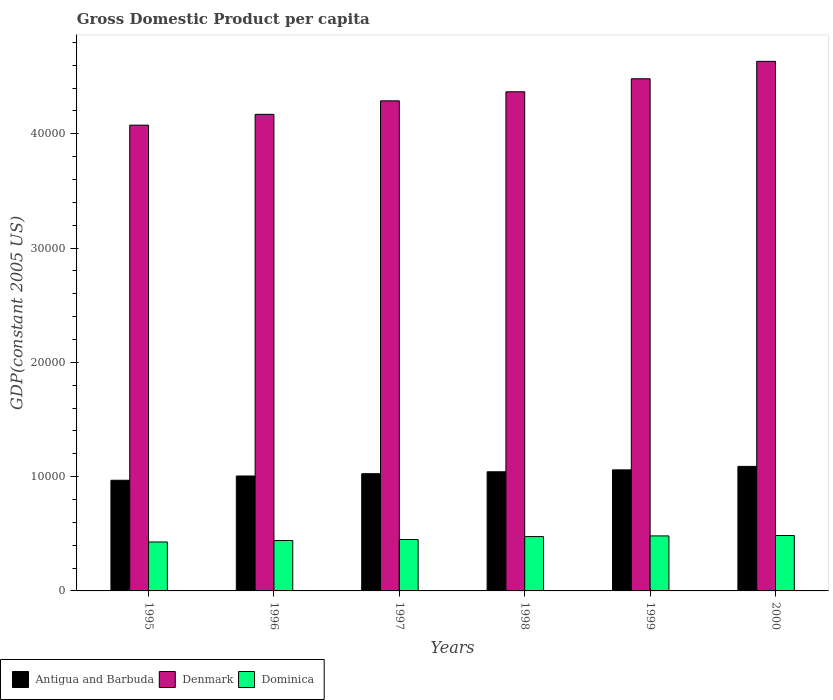How many different coloured bars are there?
Give a very brief answer. 3. How many groups of bars are there?
Ensure brevity in your answer.  6. Are the number of bars per tick equal to the number of legend labels?
Make the answer very short. Yes. Are the number of bars on each tick of the X-axis equal?
Offer a terse response. Yes. How many bars are there on the 6th tick from the left?
Keep it short and to the point. 3. How many bars are there on the 2nd tick from the right?
Your answer should be very brief. 3. What is the label of the 5th group of bars from the left?
Your answer should be very brief. 1999. In how many cases, is the number of bars for a given year not equal to the number of legend labels?
Offer a very short reply. 0. What is the GDP per capita in Antigua and Barbuda in 1997?
Make the answer very short. 1.03e+04. Across all years, what is the maximum GDP per capita in Denmark?
Your answer should be very brief. 4.63e+04. Across all years, what is the minimum GDP per capita in Denmark?
Provide a short and direct response. 4.08e+04. In which year was the GDP per capita in Antigua and Barbuda maximum?
Provide a short and direct response. 2000. In which year was the GDP per capita in Dominica minimum?
Your response must be concise. 1995. What is the total GDP per capita in Dominica in the graph?
Provide a short and direct response. 2.76e+04. What is the difference between the GDP per capita in Denmark in 1997 and that in 1998?
Give a very brief answer. -792.36. What is the difference between the GDP per capita in Antigua and Barbuda in 2000 and the GDP per capita in Denmark in 1998?
Make the answer very short. -3.28e+04. What is the average GDP per capita in Dominica per year?
Offer a terse response. 4600.96. In the year 1998, what is the difference between the GDP per capita in Antigua and Barbuda and GDP per capita in Denmark?
Make the answer very short. -3.33e+04. What is the ratio of the GDP per capita in Denmark in 1995 to that in 1999?
Ensure brevity in your answer.  0.91. What is the difference between the highest and the second highest GDP per capita in Antigua and Barbuda?
Provide a short and direct response. 303.82. What is the difference between the highest and the lowest GDP per capita in Antigua and Barbuda?
Provide a succinct answer. 1213.7. In how many years, is the GDP per capita in Dominica greater than the average GDP per capita in Dominica taken over all years?
Give a very brief answer. 3. Is the sum of the GDP per capita in Antigua and Barbuda in 1997 and 1998 greater than the maximum GDP per capita in Denmark across all years?
Your answer should be very brief. No. What does the 1st bar from the left in 1998 represents?
Ensure brevity in your answer.  Antigua and Barbuda. What does the 2nd bar from the right in 1995 represents?
Provide a short and direct response. Denmark. How many bars are there?
Give a very brief answer. 18. Are all the bars in the graph horizontal?
Make the answer very short. No. What is the difference between two consecutive major ticks on the Y-axis?
Provide a succinct answer. 10000. Are the values on the major ticks of Y-axis written in scientific E-notation?
Provide a succinct answer. No. Does the graph contain grids?
Provide a short and direct response. No. What is the title of the graph?
Provide a short and direct response. Gross Domestic Product per capita. Does "Guatemala" appear as one of the legend labels in the graph?
Offer a very short reply. No. What is the label or title of the Y-axis?
Provide a short and direct response. GDP(constant 2005 US). What is the GDP(constant 2005 US) of Antigua and Barbuda in 1995?
Your response must be concise. 9684.08. What is the GDP(constant 2005 US) of Denmark in 1995?
Your answer should be very brief. 4.08e+04. What is the GDP(constant 2005 US) of Dominica in 1995?
Give a very brief answer. 4282.18. What is the GDP(constant 2005 US) of Antigua and Barbuda in 1996?
Offer a very short reply. 1.01e+04. What is the GDP(constant 2005 US) of Denmark in 1996?
Make the answer very short. 4.17e+04. What is the GDP(constant 2005 US) in Dominica in 1996?
Your response must be concise. 4408.96. What is the GDP(constant 2005 US) in Antigua and Barbuda in 1997?
Offer a very short reply. 1.03e+04. What is the GDP(constant 2005 US) of Denmark in 1997?
Your response must be concise. 4.29e+04. What is the GDP(constant 2005 US) of Dominica in 1997?
Your answer should be very brief. 4499.35. What is the GDP(constant 2005 US) of Antigua and Barbuda in 1998?
Provide a succinct answer. 1.04e+04. What is the GDP(constant 2005 US) in Denmark in 1998?
Ensure brevity in your answer.  4.37e+04. What is the GDP(constant 2005 US) of Dominica in 1998?
Make the answer very short. 4754.31. What is the GDP(constant 2005 US) of Antigua and Barbuda in 1999?
Ensure brevity in your answer.  1.06e+04. What is the GDP(constant 2005 US) in Denmark in 1999?
Ensure brevity in your answer.  4.48e+04. What is the GDP(constant 2005 US) in Dominica in 1999?
Your response must be concise. 4813.71. What is the GDP(constant 2005 US) in Antigua and Barbuda in 2000?
Your answer should be very brief. 1.09e+04. What is the GDP(constant 2005 US) of Denmark in 2000?
Your answer should be very brief. 4.63e+04. What is the GDP(constant 2005 US) in Dominica in 2000?
Offer a terse response. 4847.24. Across all years, what is the maximum GDP(constant 2005 US) in Antigua and Barbuda?
Provide a succinct answer. 1.09e+04. Across all years, what is the maximum GDP(constant 2005 US) in Denmark?
Your response must be concise. 4.63e+04. Across all years, what is the maximum GDP(constant 2005 US) of Dominica?
Your answer should be very brief. 4847.24. Across all years, what is the minimum GDP(constant 2005 US) of Antigua and Barbuda?
Your answer should be compact. 9684.08. Across all years, what is the minimum GDP(constant 2005 US) in Denmark?
Your response must be concise. 4.08e+04. Across all years, what is the minimum GDP(constant 2005 US) of Dominica?
Give a very brief answer. 4282.18. What is the total GDP(constant 2005 US) of Antigua and Barbuda in the graph?
Your answer should be very brief. 6.19e+04. What is the total GDP(constant 2005 US) of Denmark in the graph?
Provide a short and direct response. 2.60e+05. What is the total GDP(constant 2005 US) of Dominica in the graph?
Make the answer very short. 2.76e+04. What is the difference between the GDP(constant 2005 US) in Antigua and Barbuda in 1995 and that in 1996?
Provide a short and direct response. -373.66. What is the difference between the GDP(constant 2005 US) of Denmark in 1995 and that in 1996?
Your response must be concise. -945.39. What is the difference between the GDP(constant 2005 US) of Dominica in 1995 and that in 1996?
Provide a succinct answer. -126.78. What is the difference between the GDP(constant 2005 US) in Antigua and Barbuda in 1995 and that in 1997?
Provide a short and direct response. -574.88. What is the difference between the GDP(constant 2005 US) of Denmark in 1995 and that in 1997?
Keep it short and to the point. -2126.75. What is the difference between the GDP(constant 2005 US) in Dominica in 1995 and that in 1997?
Provide a succinct answer. -217.17. What is the difference between the GDP(constant 2005 US) in Antigua and Barbuda in 1995 and that in 1998?
Your answer should be very brief. -742.12. What is the difference between the GDP(constant 2005 US) of Denmark in 1995 and that in 1998?
Your answer should be compact. -2919.11. What is the difference between the GDP(constant 2005 US) of Dominica in 1995 and that in 1998?
Offer a terse response. -472.13. What is the difference between the GDP(constant 2005 US) of Antigua and Barbuda in 1995 and that in 1999?
Your answer should be very brief. -909.88. What is the difference between the GDP(constant 2005 US) of Denmark in 1995 and that in 1999?
Give a very brief answer. -4058.22. What is the difference between the GDP(constant 2005 US) of Dominica in 1995 and that in 1999?
Your answer should be very brief. -531.53. What is the difference between the GDP(constant 2005 US) of Antigua and Barbuda in 1995 and that in 2000?
Offer a very short reply. -1213.7. What is the difference between the GDP(constant 2005 US) in Denmark in 1995 and that in 2000?
Give a very brief answer. -5582.34. What is the difference between the GDP(constant 2005 US) of Dominica in 1995 and that in 2000?
Your response must be concise. -565.06. What is the difference between the GDP(constant 2005 US) in Antigua and Barbuda in 1996 and that in 1997?
Ensure brevity in your answer.  -201.21. What is the difference between the GDP(constant 2005 US) in Denmark in 1996 and that in 1997?
Provide a succinct answer. -1181.36. What is the difference between the GDP(constant 2005 US) in Dominica in 1996 and that in 1997?
Ensure brevity in your answer.  -90.39. What is the difference between the GDP(constant 2005 US) in Antigua and Barbuda in 1996 and that in 1998?
Make the answer very short. -368.46. What is the difference between the GDP(constant 2005 US) of Denmark in 1996 and that in 1998?
Your answer should be very brief. -1973.72. What is the difference between the GDP(constant 2005 US) of Dominica in 1996 and that in 1998?
Give a very brief answer. -345.35. What is the difference between the GDP(constant 2005 US) in Antigua and Barbuda in 1996 and that in 1999?
Provide a short and direct response. -536.22. What is the difference between the GDP(constant 2005 US) in Denmark in 1996 and that in 1999?
Give a very brief answer. -3112.83. What is the difference between the GDP(constant 2005 US) in Dominica in 1996 and that in 1999?
Give a very brief answer. -404.75. What is the difference between the GDP(constant 2005 US) of Antigua and Barbuda in 1996 and that in 2000?
Your answer should be very brief. -840.03. What is the difference between the GDP(constant 2005 US) in Denmark in 1996 and that in 2000?
Offer a terse response. -4636.95. What is the difference between the GDP(constant 2005 US) in Dominica in 1996 and that in 2000?
Make the answer very short. -438.28. What is the difference between the GDP(constant 2005 US) in Antigua and Barbuda in 1997 and that in 1998?
Make the answer very short. -167.25. What is the difference between the GDP(constant 2005 US) of Denmark in 1997 and that in 1998?
Give a very brief answer. -792.36. What is the difference between the GDP(constant 2005 US) in Dominica in 1997 and that in 1998?
Give a very brief answer. -254.96. What is the difference between the GDP(constant 2005 US) in Antigua and Barbuda in 1997 and that in 1999?
Provide a short and direct response. -335. What is the difference between the GDP(constant 2005 US) of Denmark in 1997 and that in 1999?
Keep it short and to the point. -1931.47. What is the difference between the GDP(constant 2005 US) in Dominica in 1997 and that in 1999?
Keep it short and to the point. -314.36. What is the difference between the GDP(constant 2005 US) in Antigua and Barbuda in 1997 and that in 2000?
Provide a short and direct response. -638.82. What is the difference between the GDP(constant 2005 US) of Denmark in 1997 and that in 2000?
Your response must be concise. -3455.59. What is the difference between the GDP(constant 2005 US) of Dominica in 1997 and that in 2000?
Ensure brevity in your answer.  -347.89. What is the difference between the GDP(constant 2005 US) in Antigua and Barbuda in 1998 and that in 1999?
Ensure brevity in your answer.  -167.75. What is the difference between the GDP(constant 2005 US) of Denmark in 1998 and that in 1999?
Provide a succinct answer. -1139.11. What is the difference between the GDP(constant 2005 US) of Dominica in 1998 and that in 1999?
Provide a short and direct response. -59.4. What is the difference between the GDP(constant 2005 US) in Antigua and Barbuda in 1998 and that in 2000?
Offer a terse response. -471.57. What is the difference between the GDP(constant 2005 US) in Denmark in 1998 and that in 2000?
Your answer should be very brief. -2663.23. What is the difference between the GDP(constant 2005 US) in Dominica in 1998 and that in 2000?
Offer a terse response. -92.93. What is the difference between the GDP(constant 2005 US) in Antigua and Barbuda in 1999 and that in 2000?
Provide a short and direct response. -303.82. What is the difference between the GDP(constant 2005 US) of Denmark in 1999 and that in 2000?
Your response must be concise. -1524.12. What is the difference between the GDP(constant 2005 US) of Dominica in 1999 and that in 2000?
Make the answer very short. -33.53. What is the difference between the GDP(constant 2005 US) in Antigua and Barbuda in 1995 and the GDP(constant 2005 US) in Denmark in 1996?
Your answer should be very brief. -3.20e+04. What is the difference between the GDP(constant 2005 US) of Antigua and Barbuda in 1995 and the GDP(constant 2005 US) of Dominica in 1996?
Your answer should be compact. 5275.12. What is the difference between the GDP(constant 2005 US) of Denmark in 1995 and the GDP(constant 2005 US) of Dominica in 1996?
Keep it short and to the point. 3.64e+04. What is the difference between the GDP(constant 2005 US) in Antigua and Barbuda in 1995 and the GDP(constant 2005 US) in Denmark in 1997?
Make the answer very short. -3.32e+04. What is the difference between the GDP(constant 2005 US) in Antigua and Barbuda in 1995 and the GDP(constant 2005 US) in Dominica in 1997?
Keep it short and to the point. 5184.73. What is the difference between the GDP(constant 2005 US) of Denmark in 1995 and the GDP(constant 2005 US) of Dominica in 1997?
Your answer should be compact. 3.63e+04. What is the difference between the GDP(constant 2005 US) of Antigua and Barbuda in 1995 and the GDP(constant 2005 US) of Denmark in 1998?
Your response must be concise. -3.40e+04. What is the difference between the GDP(constant 2005 US) of Antigua and Barbuda in 1995 and the GDP(constant 2005 US) of Dominica in 1998?
Your response must be concise. 4929.77. What is the difference between the GDP(constant 2005 US) of Denmark in 1995 and the GDP(constant 2005 US) of Dominica in 1998?
Provide a succinct answer. 3.60e+04. What is the difference between the GDP(constant 2005 US) of Antigua and Barbuda in 1995 and the GDP(constant 2005 US) of Denmark in 1999?
Provide a succinct answer. -3.51e+04. What is the difference between the GDP(constant 2005 US) of Antigua and Barbuda in 1995 and the GDP(constant 2005 US) of Dominica in 1999?
Provide a succinct answer. 4870.37. What is the difference between the GDP(constant 2005 US) of Denmark in 1995 and the GDP(constant 2005 US) of Dominica in 1999?
Keep it short and to the point. 3.59e+04. What is the difference between the GDP(constant 2005 US) of Antigua and Barbuda in 1995 and the GDP(constant 2005 US) of Denmark in 2000?
Provide a succinct answer. -3.67e+04. What is the difference between the GDP(constant 2005 US) in Antigua and Barbuda in 1995 and the GDP(constant 2005 US) in Dominica in 2000?
Keep it short and to the point. 4836.84. What is the difference between the GDP(constant 2005 US) in Denmark in 1995 and the GDP(constant 2005 US) in Dominica in 2000?
Provide a short and direct response. 3.59e+04. What is the difference between the GDP(constant 2005 US) of Antigua and Barbuda in 1996 and the GDP(constant 2005 US) of Denmark in 1997?
Provide a succinct answer. -3.28e+04. What is the difference between the GDP(constant 2005 US) in Antigua and Barbuda in 1996 and the GDP(constant 2005 US) in Dominica in 1997?
Offer a terse response. 5558.39. What is the difference between the GDP(constant 2005 US) of Denmark in 1996 and the GDP(constant 2005 US) of Dominica in 1997?
Provide a succinct answer. 3.72e+04. What is the difference between the GDP(constant 2005 US) in Antigua and Barbuda in 1996 and the GDP(constant 2005 US) in Denmark in 1998?
Offer a very short reply. -3.36e+04. What is the difference between the GDP(constant 2005 US) of Antigua and Barbuda in 1996 and the GDP(constant 2005 US) of Dominica in 1998?
Your response must be concise. 5303.43. What is the difference between the GDP(constant 2005 US) in Denmark in 1996 and the GDP(constant 2005 US) in Dominica in 1998?
Provide a short and direct response. 3.70e+04. What is the difference between the GDP(constant 2005 US) in Antigua and Barbuda in 1996 and the GDP(constant 2005 US) in Denmark in 1999?
Offer a terse response. -3.48e+04. What is the difference between the GDP(constant 2005 US) of Antigua and Barbuda in 1996 and the GDP(constant 2005 US) of Dominica in 1999?
Your answer should be compact. 5244.04. What is the difference between the GDP(constant 2005 US) of Denmark in 1996 and the GDP(constant 2005 US) of Dominica in 1999?
Your answer should be compact. 3.69e+04. What is the difference between the GDP(constant 2005 US) of Antigua and Barbuda in 1996 and the GDP(constant 2005 US) of Denmark in 2000?
Offer a very short reply. -3.63e+04. What is the difference between the GDP(constant 2005 US) in Antigua and Barbuda in 1996 and the GDP(constant 2005 US) in Dominica in 2000?
Your answer should be very brief. 5210.51. What is the difference between the GDP(constant 2005 US) of Denmark in 1996 and the GDP(constant 2005 US) of Dominica in 2000?
Your answer should be very brief. 3.69e+04. What is the difference between the GDP(constant 2005 US) in Antigua and Barbuda in 1997 and the GDP(constant 2005 US) in Denmark in 1998?
Provide a short and direct response. -3.34e+04. What is the difference between the GDP(constant 2005 US) in Antigua and Barbuda in 1997 and the GDP(constant 2005 US) in Dominica in 1998?
Offer a very short reply. 5504.65. What is the difference between the GDP(constant 2005 US) in Denmark in 1997 and the GDP(constant 2005 US) in Dominica in 1998?
Ensure brevity in your answer.  3.81e+04. What is the difference between the GDP(constant 2005 US) in Antigua and Barbuda in 1997 and the GDP(constant 2005 US) in Denmark in 1999?
Your answer should be very brief. -3.46e+04. What is the difference between the GDP(constant 2005 US) of Antigua and Barbuda in 1997 and the GDP(constant 2005 US) of Dominica in 1999?
Keep it short and to the point. 5445.25. What is the difference between the GDP(constant 2005 US) in Denmark in 1997 and the GDP(constant 2005 US) in Dominica in 1999?
Offer a terse response. 3.81e+04. What is the difference between the GDP(constant 2005 US) in Antigua and Barbuda in 1997 and the GDP(constant 2005 US) in Denmark in 2000?
Provide a short and direct response. -3.61e+04. What is the difference between the GDP(constant 2005 US) of Antigua and Barbuda in 1997 and the GDP(constant 2005 US) of Dominica in 2000?
Your response must be concise. 5411.72. What is the difference between the GDP(constant 2005 US) of Denmark in 1997 and the GDP(constant 2005 US) of Dominica in 2000?
Your answer should be compact. 3.80e+04. What is the difference between the GDP(constant 2005 US) in Antigua and Barbuda in 1998 and the GDP(constant 2005 US) in Denmark in 1999?
Offer a very short reply. -3.44e+04. What is the difference between the GDP(constant 2005 US) in Antigua and Barbuda in 1998 and the GDP(constant 2005 US) in Dominica in 1999?
Provide a short and direct response. 5612.5. What is the difference between the GDP(constant 2005 US) in Denmark in 1998 and the GDP(constant 2005 US) in Dominica in 1999?
Keep it short and to the point. 3.89e+04. What is the difference between the GDP(constant 2005 US) of Antigua and Barbuda in 1998 and the GDP(constant 2005 US) of Denmark in 2000?
Make the answer very short. -3.59e+04. What is the difference between the GDP(constant 2005 US) of Antigua and Barbuda in 1998 and the GDP(constant 2005 US) of Dominica in 2000?
Your answer should be very brief. 5578.97. What is the difference between the GDP(constant 2005 US) in Denmark in 1998 and the GDP(constant 2005 US) in Dominica in 2000?
Provide a succinct answer. 3.88e+04. What is the difference between the GDP(constant 2005 US) in Antigua and Barbuda in 1999 and the GDP(constant 2005 US) in Denmark in 2000?
Offer a terse response. -3.57e+04. What is the difference between the GDP(constant 2005 US) in Antigua and Barbuda in 1999 and the GDP(constant 2005 US) in Dominica in 2000?
Your response must be concise. 5746.72. What is the difference between the GDP(constant 2005 US) of Denmark in 1999 and the GDP(constant 2005 US) of Dominica in 2000?
Your answer should be very brief. 4.00e+04. What is the average GDP(constant 2005 US) in Antigua and Barbuda per year?
Give a very brief answer. 1.03e+04. What is the average GDP(constant 2005 US) of Denmark per year?
Give a very brief answer. 4.34e+04. What is the average GDP(constant 2005 US) of Dominica per year?
Ensure brevity in your answer.  4600.96. In the year 1995, what is the difference between the GDP(constant 2005 US) in Antigua and Barbuda and GDP(constant 2005 US) in Denmark?
Ensure brevity in your answer.  -3.11e+04. In the year 1995, what is the difference between the GDP(constant 2005 US) in Antigua and Barbuda and GDP(constant 2005 US) in Dominica?
Give a very brief answer. 5401.9. In the year 1995, what is the difference between the GDP(constant 2005 US) in Denmark and GDP(constant 2005 US) in Dominica?
Your response must be concise. 3.65e+04. In the year 1996, what is the difference between the GDP(constant 2005 US) in Antigua and Barbuda and GDP(constant 2005 US) in Denmark?
Offer a terse response. -3.16e+04. In the year 1996, what is the difference between the GDP(constant 2005 US) of Antigua and Barbuda and GDP(constant 2005 US) of Dominica?
Your answer should be compact. 5648.79. In the year 1996, what is the difference between the GDP(constant 2005 US) in Denmark and GDP(constant 2005 US) in Dominica?
Your response must be concise. 3.73e+04. In the year 1997, what is the difference between the GDP(constant 2005 US) in Antigua and Barbuda and GDP(constant 2005 US) in Denmark?
Offer a very short reply. -3.26e+04. In the year 1997, what is the difference between the GDP(constant 2005 US) of Antigua and Barbuda and GDP(constant 2005 US) of Dominica?
Make the answer very short. 5759.6. In the year 1997, what is the difference between the GDP(constant 2005 US) in Denmark and GDP(constant 2005 US) in Dominica?
Offer a very short reply. 3.84e+04. In the year 1998, what is the difference between the GDP(constant 2005 US) in Antigua and Barbuda and GDP(constant 2005 US) in Denmark?
Your answer should be very brief. -3.33e+04. In the year 1998, what is the difference between the GDP(constant 2005 US) in Antigua and Barbuda and GDP(constant 2005 US) in Dominica?
Your response must be concise. 5671.89. In the year 1998, what is the difference between the GDP(constant 2005 US) in Denmark and GDP(constant 2005 US) in Dominica?
Offer a terse response. 3.89e+04. In the year 1999, what is the difference between the GDP(constant 2005 US) of Antigua and Barbuda and GDP(constant 2005 US) of Denmark?
Provide a succinct answer. -3.42e+04. In the year 1999, what is the difference between the GDP(constant 2005 US) of Antigua and Barbuda and GDP(constant 2005 US) of Dominica?
Your response must be concise. 5780.25. In the year 1999, what is the difference between the GDP(constant 2005 US) of Denmark and GDP(constant 2005 US) of Dominica?
Offer a very short reply. 4.00e+04. In the year 2000, what is the difference between the GDP(constant 2005 US) in Antigua and Barbuda and GDP(constant 2005 US) in Denmark?
Ensure brevity in your answer.  -3.54e+04. In the year 2000, what is the difference between the GDP(constant 2005 US) of Antigua and Barbuda and GDP(constant 2005 US) of Dominica?
Offer a very short reply. 6050.54. In the year 2000, what is the difference between the GDP(constant 2005 US) in Denmark and GDP(constant 2005 US) in Dominica?
Offer a very short reply. 4.15e+04. What is the ratio of the GDP(constant 2005 US) in Antigua and Barbuda in 1995 to that in 1996?
Your answer should be very brief. 0.96. What is the ratio of the GDP(constant 2005 US) in Denmark in 1995 to that in 1996?
Your answer should be compact. 0.98. What is the ratio of the GDP(constant 2005 US) in Dominica in 1995 to that in 1996?
Your response must be concise. 0.97. What is the ratio of the GDP(constant 2005 US) of Antigua and Barbuda in 1995 to that in 1997?
Provide a succinct answer. 0.94. What is the ratio of the GDP(constant 2005 US) in Denmark in 1995 to that in 1997?
Provide a succinct answer. 0.95. What is the ratio of the GDP(constant 2005 US) of Dominica in 1995 to that in 1997?
Provide a succinct answer. 0.95. What is the ratio of the GDP(constant 2005 US) of Antigua and Barbuda in 1995 to that in 1998?
Provide a succinct answer. 0.93. What is the ratio of the GDP(constant 2005 US) in Denmark in 1995 to that in 1998?
Keep it short and to the point. 0.93. What is the ratio of the GDP(constant 2005 US) in Dominica in 1995 to that in 1998?
Keep it short and to the point. 0.9. What is the ratio of the GDP(constant 2005 US) of Antigua and Barbuda in 1995 to that in 1999?
Ensure brevity in your answer.  0.91. What is the ratio of the GDP(constant 2005 US) of Denmark in 1995 to that in 1999?
Give a very brief answer. 0.91. What is the ratio of the GDP(constant 2005 US) of Dominica in 1995 to that in 1999?
Give a very brief answer. 0.89. What is the ratio of the GDP(constant 2005 US) in Antigua and Barbuda in 1995 to that in 2000?
Keep it short and to the point. 0.89. What is the ratio of the GDP(constant 2005 US) of Denmark in 1995 to that in 2000?
Keep it short and to the point. 0.88. What is the ratio of the GDP(constant 2005 US) in Dominica in 1995 to that in 2000?
Provide a succinct answer. 0.88. What is the ratio of the GDP(constant 2005 US) in Antigua and Barbuda in 1996 to that in 1997?
Provide a succinct answer. 0.98. What is the ratio of the GDP(constant 2005 US) of Denmark in 1996 to that in 1997?
Keep it short and to the point. 0.97. What is the ratio of the GDP(constant 2005 US) of Dominica in 1996 to that in 1997?
Keep it short and to the point. 0.98. What is the ratio of the GDP(constant 2005 US) in Antigua and Barbuda in 1996 to that in 1998?
Your answer should be very brief. 0.96. What is the ratio of the GDP(constant 2005 US) of Denmark in 1996 to that in 1998?
Provide a succinct answer. 0.95. What is the ratio of the GDP(constant 2005 US) in Dominica in 1996 to that in 1998?
Your response must be concise. 0.93. What is the ratio of the GDP(constant 2005 US) in Antigua and Barbuda in 1996 to that in 1999?
Make the answer very short. 0.95. What is the ratio of the GDP(constant 2005 US) of Denmark in 1996 to that in 1999?
Provide a succinct answer. 0.93. What is the ratio of the GDP(constant 2005 US) in Dominica in 1996 to that in 1999?
Give a very brief answer. 0.92. What is the ratio of the GDP(constant 2005 US) in Antigua and Barbuda in 1996 to that in 2000?
Your response must be concise. 0.92. What is the ratio of the GDP(constant 2005 US) in Denmark in 1996 to that in 2000?
Offer a terse response. 0.9. What is the ratio of the GDP(constant 2005 US) of Dominica in 1996 to that in 2000?
Make the answer very short. 0.91. What is the ratio of the GDP(constant 2005 US) in Denmark in 1997 to that in 1998?
Provide a succinct answer. 0.98. What is the ratio of the GDP(constant 2005 US) in Dominica in 1997 to that in 1998?
Keep it short and to the point. 0.95. What is the ratio of the GDP(constant 2005 US) of Antigua and Barbuda in 1997 to that in 1999?
Offer a very short reply. 0.97. What is the ratio of the GDP(constant 2005 US) in Denmark in 1997 to that in 1999?
Provide a succinct answer. 0.96. What is the ratio of the GDP(constant 2005 US) of Dominica in 1997 to that in 1999?
Make the answer very short. 0.93. What is the ratio of the GDP(constant 2005 US) of Antigua and Barbuda in 1997 to that in 2000?
Your answer should be compact. 0.94. What is the ratio of the GDP(constant 2005 US) of Denmark in 1997 to that in 2000?
Make the answer very short. 0.93. What is the ratio of the GDP(constant 2005 US) of Dominica in 1997 to that in 2000?
Provide a succinct answer. 0.93. What is the ratio of the GDP(constant 2005 US) of Antigua and Barbuda in 1998 to that in 1999?
Your answer should be very brief. 0.98. What is the ratio of the GDP(constant 2005 US) of Denmark in 1998 to that in 1999?
Give a very brief answer. 0.97. What is the ratio of the GDP(constant 2005 US) of Dominica in 1998 to that in 1999?
Your answer should be very brief. 0.99. What is the ratio of the GDP(constant 2005 US) of Antigua and Barbuda in 1998 to that in 2000?
Provide a short and direct response. 0.96. What is the ratio of the GDP(constant 2005 US) of Denmark in 1998 to that in 2000?
Ensure brevity in your answer.  0.94. What is the ratio of the GDP(constant 2005 US) of Dominica in 1998 to that in 2000?
Your answer should be very brief. 0.98. What is the ratio of the GDP(constant 2005 US) in Antigua and Barbuda in 1999 to that in 2000?
Ensure brevity in your answer.  0.97. What is the ratio of the GDP(constant 2005 US) of Denmark in 1999 to that in 2000?
Make the answer very short. 0.97. What is the difference between the highest and the second highest GDP(constant 2005 US) of Antigua and Barbuda?
Give a very brief answer. 303.82. What is the difference between the highest and the second highest GDP(constant 2005 US) in Denmark?
Ensure brevity in your answer.  1524.12. What is the difference between the highest and the second highest GDP(constant 2005 US) in Dominica?
Offer a terse response. 33.53. What is the difference between the highest and the lowest GDP(constant 2005 US) in Antigua and Barbuda?
Ensure brevity in your answer.  1213.7. What is the difference between the highest and the lowest GDP(constant 2005 US) of Denmark?
Your response must be concise. 5582.34. What is the difference between the highest and the lowest GDP(constant 2005 US) in Dominica?
Provide a short and direct response. 565.06. 